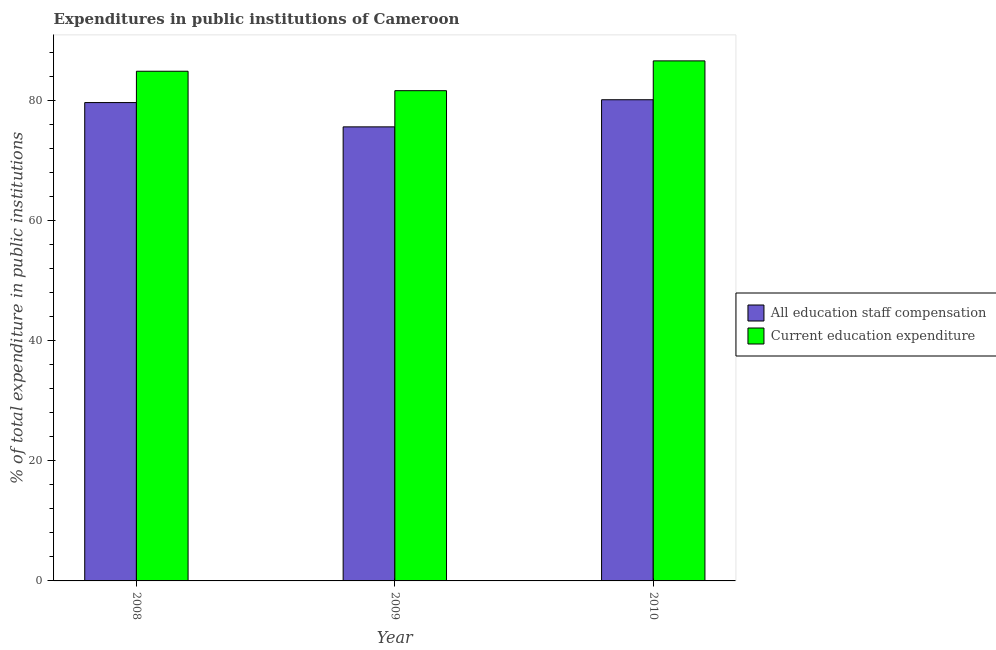How many different coloured bars are there?
Ensure brevity in your answer.  2. Are the number of bars on each tick of the X-axis equal?
Provide a succinct answer. Yes. How many bars are there on the 2nd tick from the left?
Provide a short and direct response. 2. What is the label of the 2nd group of bars from the left?
Your response must be concise. 2009. What is the expenditure in education in 2009?
Keep it short and to the point. 81.68. Across all years, what is the maximum expenditure in staff compensation?
Offer a terse response. 80.17. Across all years, what is the minimum expenditure in education?
Keep it short and to the point. 81.68. What is the total expenditure in education in the graph?
Provide a succinct answer. 253.24. What is the difference between the expenditure in staff compensation in 2009 and that in 2010?
Make the answer very short. -4.52. What is the difference between the expenditure in staff compensation in 2010 and the expenditure in education in 2009?
Your response must be concise. 4.52. What is the average expenditure in staff compensation per year?
Provide a short and direct response. 78.5. In how many years, is the expenditure in education greater than 76 %?
Provide a succinct answer. 3. What is the ratio of the expenditure in education in 2009 to that in 2010?
Provide a short and direct response. 0.94. Is the difference between the expenditure in staff compensation in 2008 and 2010 greater than the difference between the expenditure in education in 2008 and 2010?
Offer a very short reply. No. What is the difference between the highest and the second highest expenditure in staff compensation?
Give a very brief answer. 0.47. What is the difference between the highest and the lowest expenditure in education?
Provide a short and direct response. 4.97. In how many years, is the expenditure in staff compensation greater than the average expenditure in staff compensation taken over all years?
Ensure brevity in your answer.  2. Is the sum of the expenditure in staff compensation in 2008 and 2010 greater than the maximum expenditure in education across all years?
Keep it short and to the point. Yes. What does the 2nd bar from the left in 2008 represents?
Your response must be concise. Current education expenditure. What does the 1st bar from the right in 2009 represents?
Provide a succinct answer. Current education expenditure. Does the graph contain any zero values?
Provide a short and direct response. No. Where does the legend appear in the graph?
Provide a short and direct response. Center right. How many legend labels are there?
Offer a terse response. 2. How are the legend labels stacked?
Keep it short and to the point. Vertical. What is the title of the graph?
Your answer should be very brief. Expenditures in public institutions of Cameroon. What is the label or title of the Y-axis?
Offer a very short reply. % of total expenditure in public institutions. What is the % of total expenditure in public institutions in All education staff compensation in 2008?
Keep it short and to the point. 79.7. What is the % of total expenditure in public institutions in Current education expenditure in 2008?
Keep it short and to the point. 84.91. What is the % of total expenditure in public institutions in All education staff compensation in 2009?
Your answer should be compact. 75.65. What is the % of total expenditure in public institutions of Current education expenditure in 2009?
Ensure brevity in your answer.  81.68. What is the % of total expenditure in public institutions of All education staff compensation in 2010?
Keep it short and to the point. 80.17. What is the % of total expenditure in public institutions of Current education expenditure in 2010?
Your answer should be very brief. 86.64. Across all years, what is the maximum % of total expenditure in public institutions of All education staff compensation?
Make the answer very short. 80.17. Across all years, what is the maximum % of total expenditure in public institutions of Current education expenditure?
Keep it short and to the point. 86.64. Across all years, what is the minimum % of total expenditure in public institutions in All education staff compensation?
Keep it short and to the point. 75.65. Across all years, what is the minimum % of total expenditure in public institutions in Current education expenditure?
Your answer should be compact. 81.68. What is the total % of total expenditure in public institutions of All education staff compensation in the graph?
Your response must be concise. 235.51. What is the total % of total expenditure in public institutions of Current education expenditure in the graph?
Make the answer very short. 253.24. What is the difference between the % of total expenditure in public institutions in All education staff compensation in 2008 and that in 2009?
Your response must be concise. 4.05. What is the difference between the % of total expenditure in public institutions of Current education expenditure in 2008 and that in 2009?
Offer a terse response. 3.24. What is the difference between the % of total expenditure in public institutions in All education staff compensation in 2008 and that in 2010?
Your response must be concise. -0.47. What is the difference between the % of total expenditure in public institutions of Current education expenditure in 2008 and that in 2010?
Your response must be concise. -1.73. What is the difference between the % of total expenditure in public institutions in All education staff compensation in 2009 and that in 2010?
Offer a terse response. -4.52. What is the difference between the % of total expenditure in public institutions of Current education expenditure in 2009 and that in 2010?
Offer a terse response. -4.97. What is the difference between the % of total expenditure in public institutions of All education staff compensation in 2008 and the % of total expenditure in public institutions of Current education expenditure in 2009?
Offer a terse response. -1.98. What is the difference between the % of total expenditure in public institutions of All education staff compensation in 2008 and the % of total expenditure in public institutions of Current education expenditure in 2010?
Keep it short and to the point. -6.95. What is the difference between the % of total expenditure in public institutions in All education staff compensation in 2009 and the % of total expenditure in public institutions in Current education expenditure in 2010?
Keep it short and to the point. -11. What is the average % of total expenditure in public institutions in All education staff compensation per year?
Offer a very short reply. 78.5. What is the average % of total expenditure in public institutions of Current education expenditure per year?
Give a very brief answer. 84.41. In the year 2008, what is the difference between the % of total expenditure in public institutions of All education staff compensation and % of total expenditure in public institutions of Current education expenditure?
Ensure brevity in your answer.  -5.22. In the year 2009, what is the difference between the % of total expenditure in public institutions in All education staff compensation and % of total expenditure in public institutions in Current education expenditure?
Give a very brief answer. -6.03. In the year 2010, what is the difference between the % of total expenditure in public institutions in All education staff compensation and % of total expenditure in public institutions in Current education expenditure?
Keep it short and to the point. -6.47. What is the ratio of the % of total expenditure in public institutions in All education staff compensation in 2008 to that in 2009?
Give a very brief answer. 1.05. What is the ratio of the % of total expenditure in public institutions in Current education expenditure in 2008 to that in 2009?
Ensure brevity in your answer.  1.04. What is the ratio of the % of total expenditure in public institutions of All education staff compensation in 2008 to that in 2010?
Offer a terse response. 0.99. What is the ratio of the % of total expenditure in public institutions in Current education expenditure in 2008 to that in 2010?
Give a very brief answer. 0.98. What is the ratio of the % of total expenditure in public institutions of All education staff compensation in 2009 to that in 2010?
Your answer should be compact. 0.94. What is the ratio of the % of total expenditure in public institutions in Current education expenditure in 2009 to that in 2010?
Provide a succinct answer. 0.94. What is the difference between the highest and the second highest % of total expenditure in public institutions of All education staff compensation?
Keep it short and to the point. 0.47. What is the difference between the highest and the second highest % of total expenditure in public institutions in Current education expenditure?
Your response must be concise. 1.73. What is the difference between the highest and the lowest % of total expenditure in public institutions of All education staff compensation?
Your answer should be very brief. 4.52. What is the difference between the highest and the lowest % of total expenditure in public institutions of Current education expenditure?
Provide a short and direct response. 4.97. 